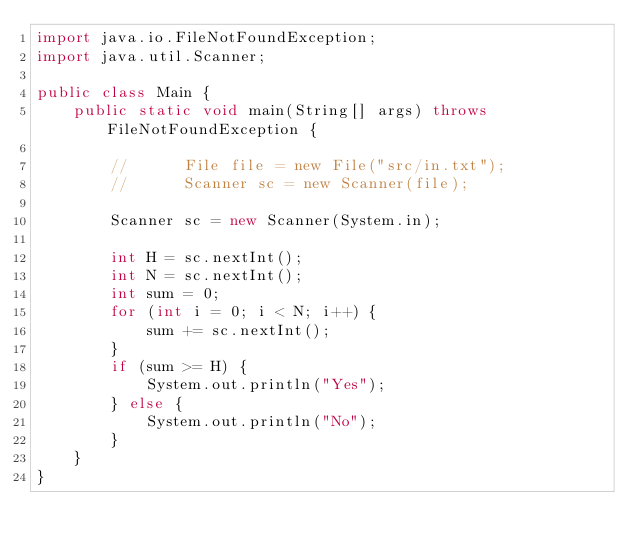<code> <loc_0><loc_0><loc_500><loc_500><_Java_>import java.io.FileNotFoundException;
import java.util.Scanner;

public class Main {
	public static void main(String[] args) throws FileNotFoundException {

		//    	File file = new File("src/in.txt");
		//    	Scanner sc = new Scanner(file);

		Scanner sc = new Scanner(System.in);

		int H = sc.nextInt();
		int N = sc.nextInt();
		int sum = 0;
		for (int i = 0; i < N; i++) {
			sum += sc.nextInt();
		}
		if (sum >= H) {
			System.out.println("Yes");
		} else {
			System.out.println("No");
		}
	}
}
</code> 